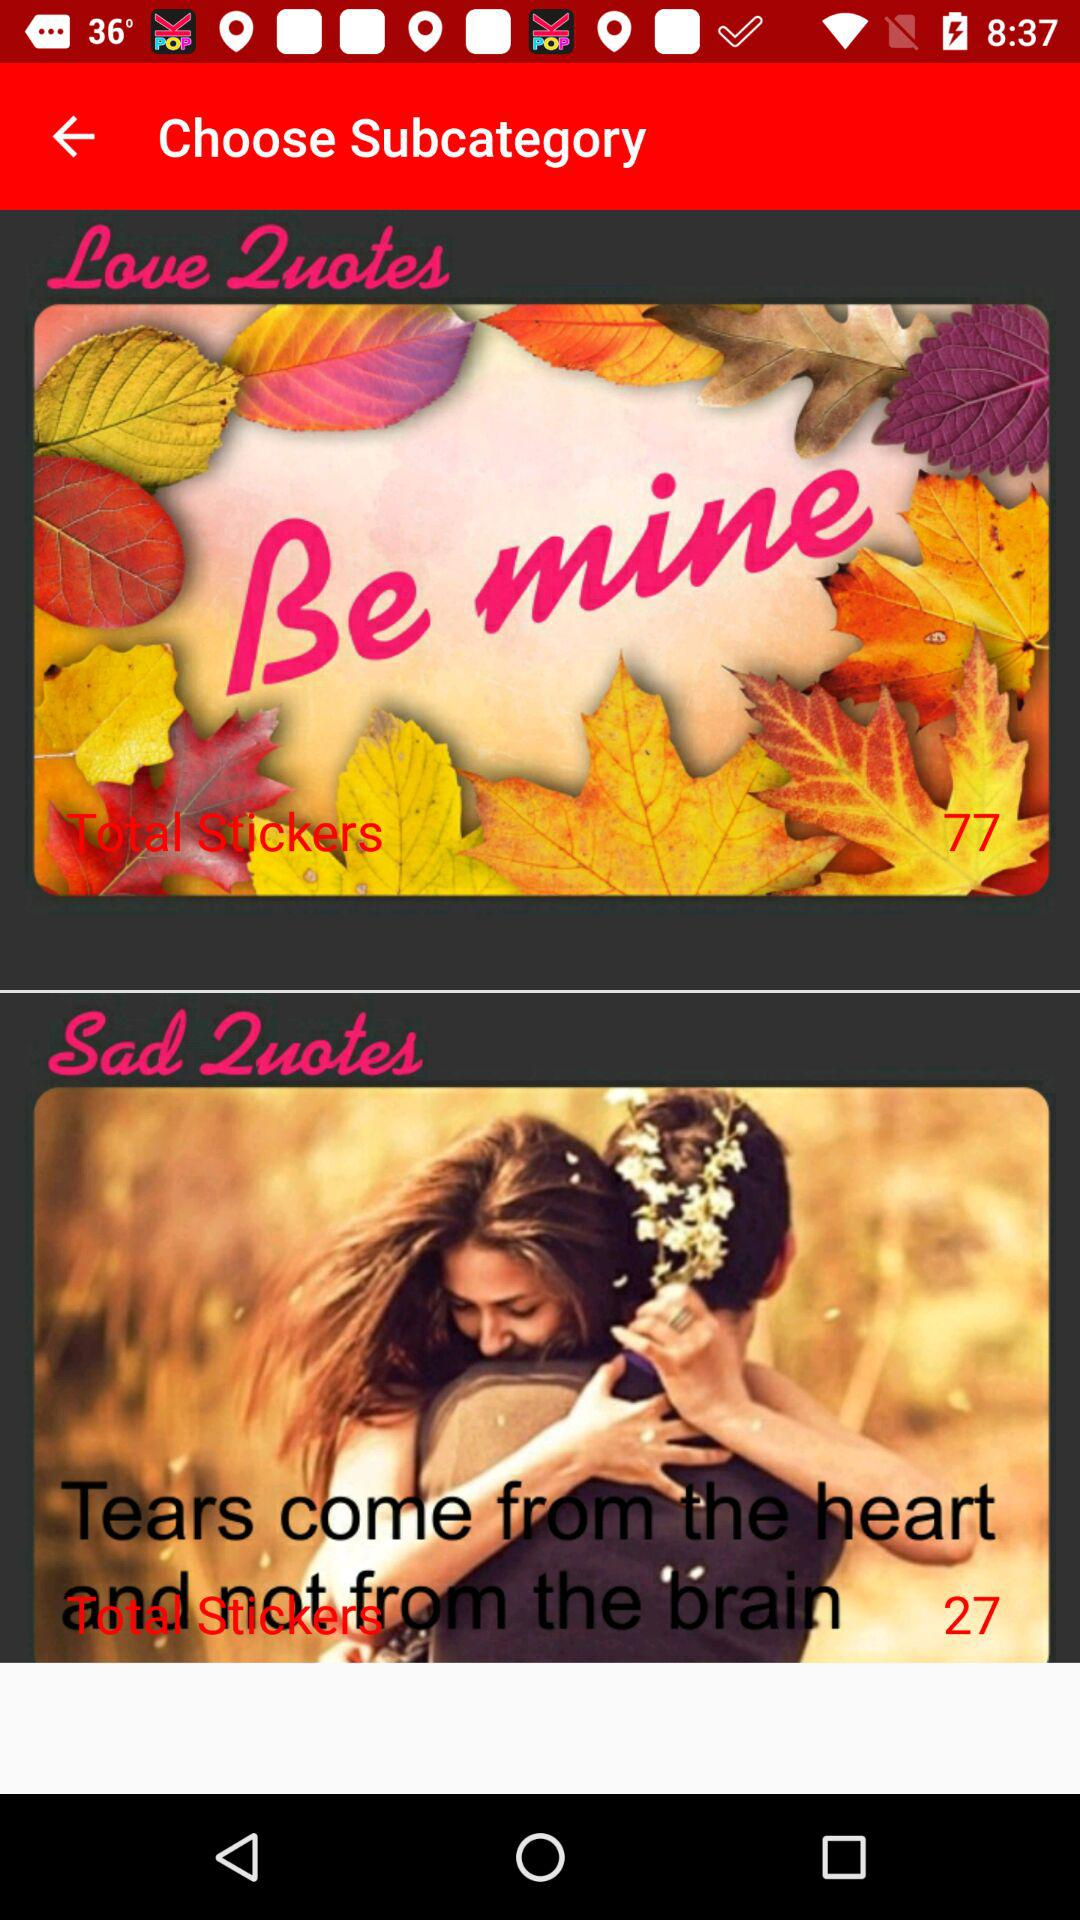Which main category was chosen?
When the provided information is insufficient, respond with <no answer>. <no answer> 